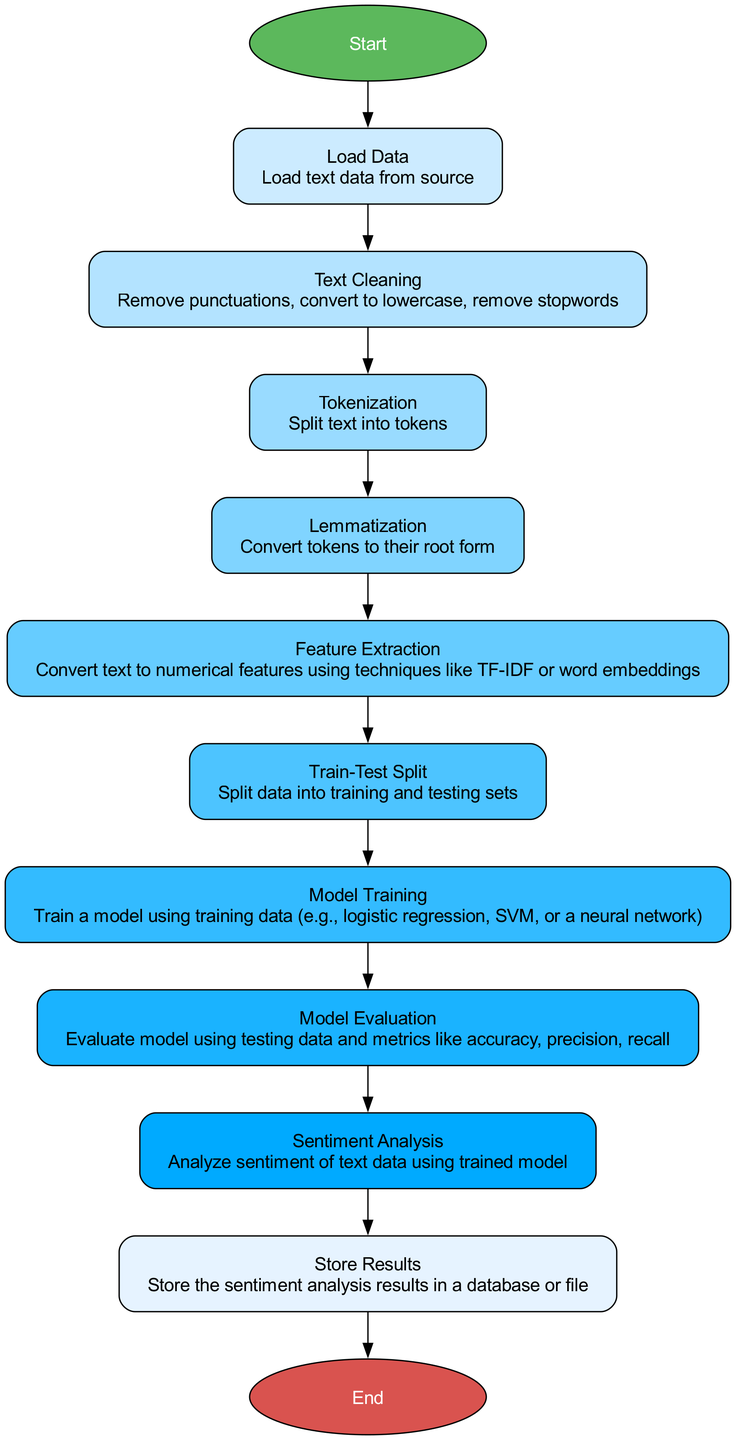What is the first step in the NLP pipeline? The first step is indicated by the 'Start' node, which connects to the 'Load Data' process. This signifies that the pipeline begins with loading the text data from the source.
Answer: Load Data How many processes are involved in the NLP pipeline? By counting all processes represented in the diagram (excluding start and end nodes), there are ten processes leading from loading data to storing results.
Answer: Ten What does the 'Feature Extraction' process do? The label in the 'Feature Extraction' node specifies that it converts text to numerical features using techniques like TF-IDF or word embeddings, conveying text into a numerical representation suitable for modeling.
Answer: Convert text to numerical features Which process follows 'Model Training' in the flowchart? The flowchart shows that the 'Model Evaluation' process directly follows the 'Model Training' step, indicating that after training, the model is assessed with testing data.
Answer: Model Evaluation What is the last step of the NLP pipeline? The last step is represented by the 'End' node, which follows the 'Store Results' process, concluding the NLP pipeline that started with loading data.
Answer: End What connects 'Tokenization' and 'Lemmatization' processes? The diagram indicates a direct connection between the 'Tokenization' process and the 'Lemmatization' process, illustrating that after splitting text into tokens, the next step is to convert those tokens to their root form.
Answer: A direct connection In terms of the execution order, what is the relationship between text cleaning and tokenization? Text cleaning precedes tokenization in the flowchart; hence, the cleaning process is essential before the text can be effectively split into tokens for further processing.
Answer: Text cleaning precedes tokenization Which process analyzes the sentiment of text data? The flowchart explicitly shows that the 'Sentiment Analysis' process is responsible for analyzing the sentiment of the cleaned and processed text data using the trained model.
Answer: Sentiment Analysis How is the data divided for training and testing in the flowchart? The 'Train-Test Split' process is specifically designated to split the data into training and testing sets, indicating a separation of data needed for model performance evaluation.
Answer: Train-Test Split 